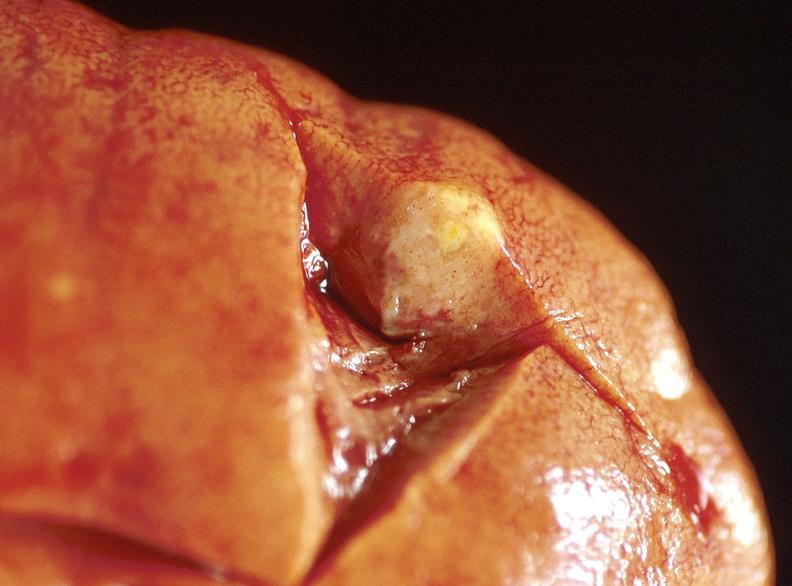what does this image show?
Answer the question using a single word or phrase. Kidney 